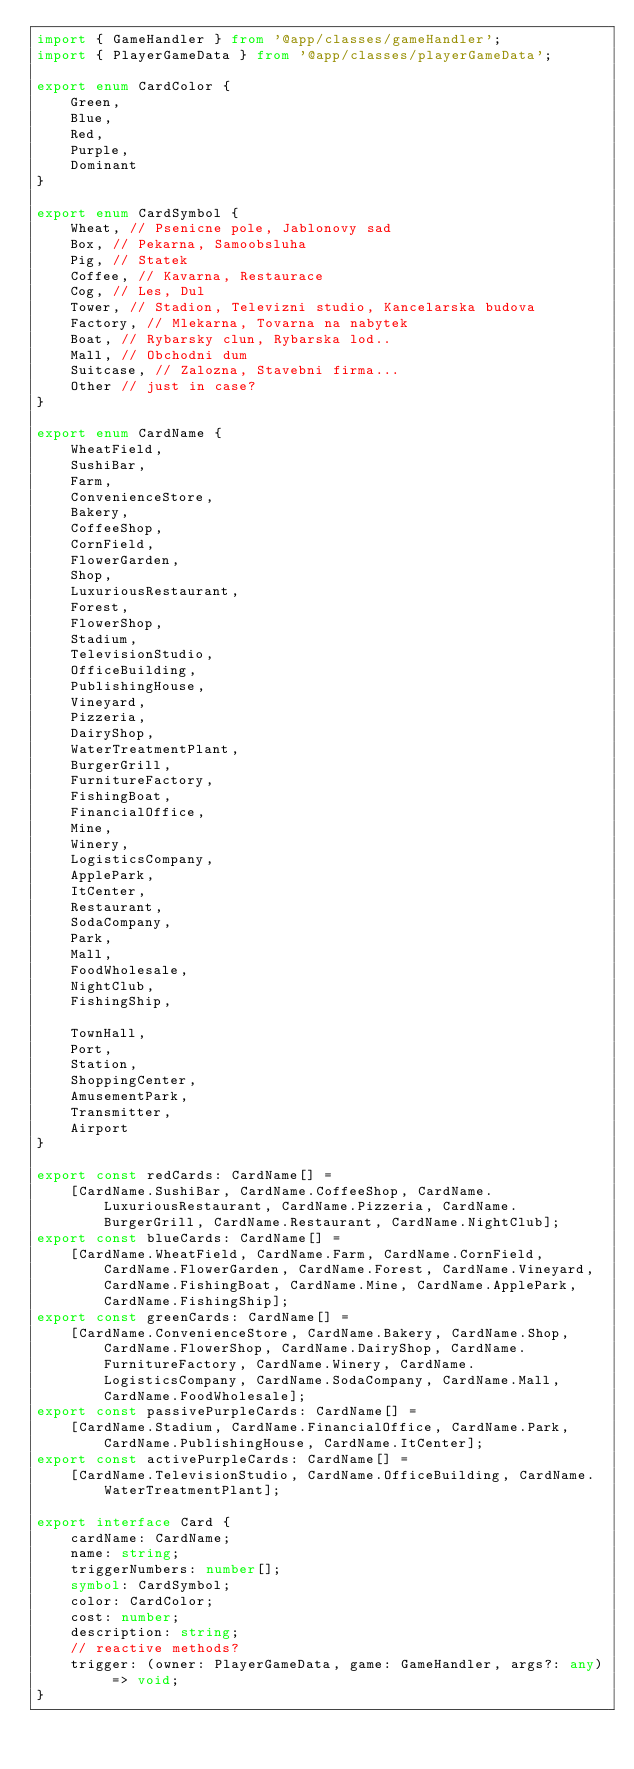Convert code to text. <code><loc_0><loc_0><loc_500><loc_500><_TypeScript_>import { GameHandler } from '@app/classes/gameHandler';
import { PlayerGameData } from '@app/classes/playerGameData';

export enum CardColor {
    Green,
    Blue,
    Red,
    Purple,
    Dominant
}

export enum CardSymbol {
    Wheat, // Psenicne pole, Jablonovy sad
    Box, // Pekarna, Samoobsluha
    Pig, // Statek
    Coffee, // Kavarna, Restaurace
    Cog, // Les, Dul
    Tower, // Stadion, Televizni studio, Kancelarska budova
    Factory, // Mlekarna, Tovarna na nabytek
    Boat, // Rybarsky clun, Rybarska lod..
    Mall, // Obchodni dum
    Suitcase, // Zalozna, Stavebni firma...
    Other // just in case?
}

export enum CardName {
    WheatField,
    SushiBar,
    Farm,
    ConvenienceStore,
    Bakery,
    CoffeeShop,
    CornField,
    FlowerGarden,
    Shop,
    LuxuriousRestaurant,
    Forest,
    FlowerShop,
    Stadium,
    TelevisionStudio,
    OfficeBuilding,
    PublishingHouse,
    Vineyard,
    Pizzeria,
    DairyShop,
    WaterTreatmentPlant,
    BurgerGrill,
    FurnitureFactory,
    FishingBoat,
    FinancialOffice,
    Mine,
    Winery,
    LogisticsCompany,
    ApplePark,
    ItCenter,
    Restaurant,
    SodaCompany,
    Park,
    Mall,
    FoodWholesale,
    NightClub,
    FishingShip,

    TownHall,
    Port,
    Station,
    ShoppingCenter,
    AmusementPark,
    Transmitter,
    Airport
}

export const redCards: CardName[] =
    [CardName.SushiBar, CardName.CoffeeShop, CardName.LuxuriousRestaurant, CardName.Pizzeria, CardName.BurgerGrill, CardName.Restaurant, CardName.NightClub];
export const blueCards: CardName[] =
    [CardName.WheatField, CardName.Farm, CardName.CornField, CardName.FlowerGarden, CardName.Forest, CardName.Vineyard, CardName.FishingBoat, CardName.Mine, CardName.ApplePark, CardName.FishingShip];
export const greenCards: CardName[] =
    [CardName.ConvenienceStore, CardName.Bakery, CardName.Shop, CardName.FlowerShop, CardName.DairyShop, CardName.FurnitureFactory, CardName.Winery, CardName.LogisticsCompany, CardName.SodaCompany, CardName.Mall, CardName.FoodWholesale];
export const passivePurpleCards: CardName[] =
    [CardName.Stadium, CardName.FinancialOffice, CardName.Park, CardName.PublishingHouse, CardName.ItCenter];
export const activePurpleCards: CardName[] =
    [CardName.TelevisionStudio, CardName.OfficeBuilding, CardName.WaterTreatmentPlant];

export interface Card {
    cardName: CardName;
    name: string;
    triggerNumbers: number[];
    symbol: CardSymbol;
    color: CardColor;
    cost: number;
    description: string;
    // reactive methods?
    trigger: (owner: PlayerGameData, game: GameHandler, args?: any) => void;
}
</code> 